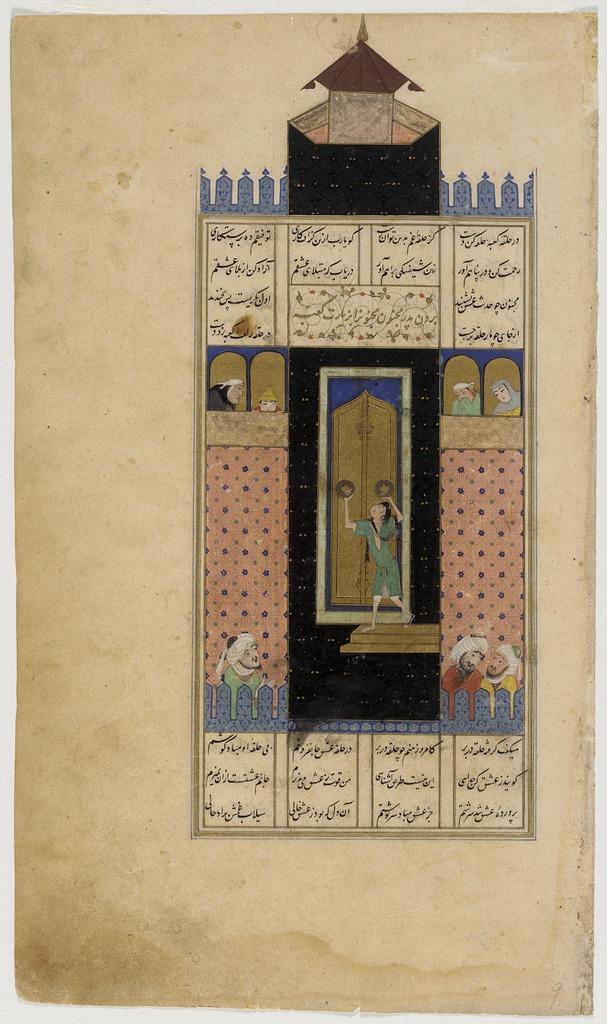Describe this image in one or two sentences. In the picture I can see the painting of a castle and a few persons. 